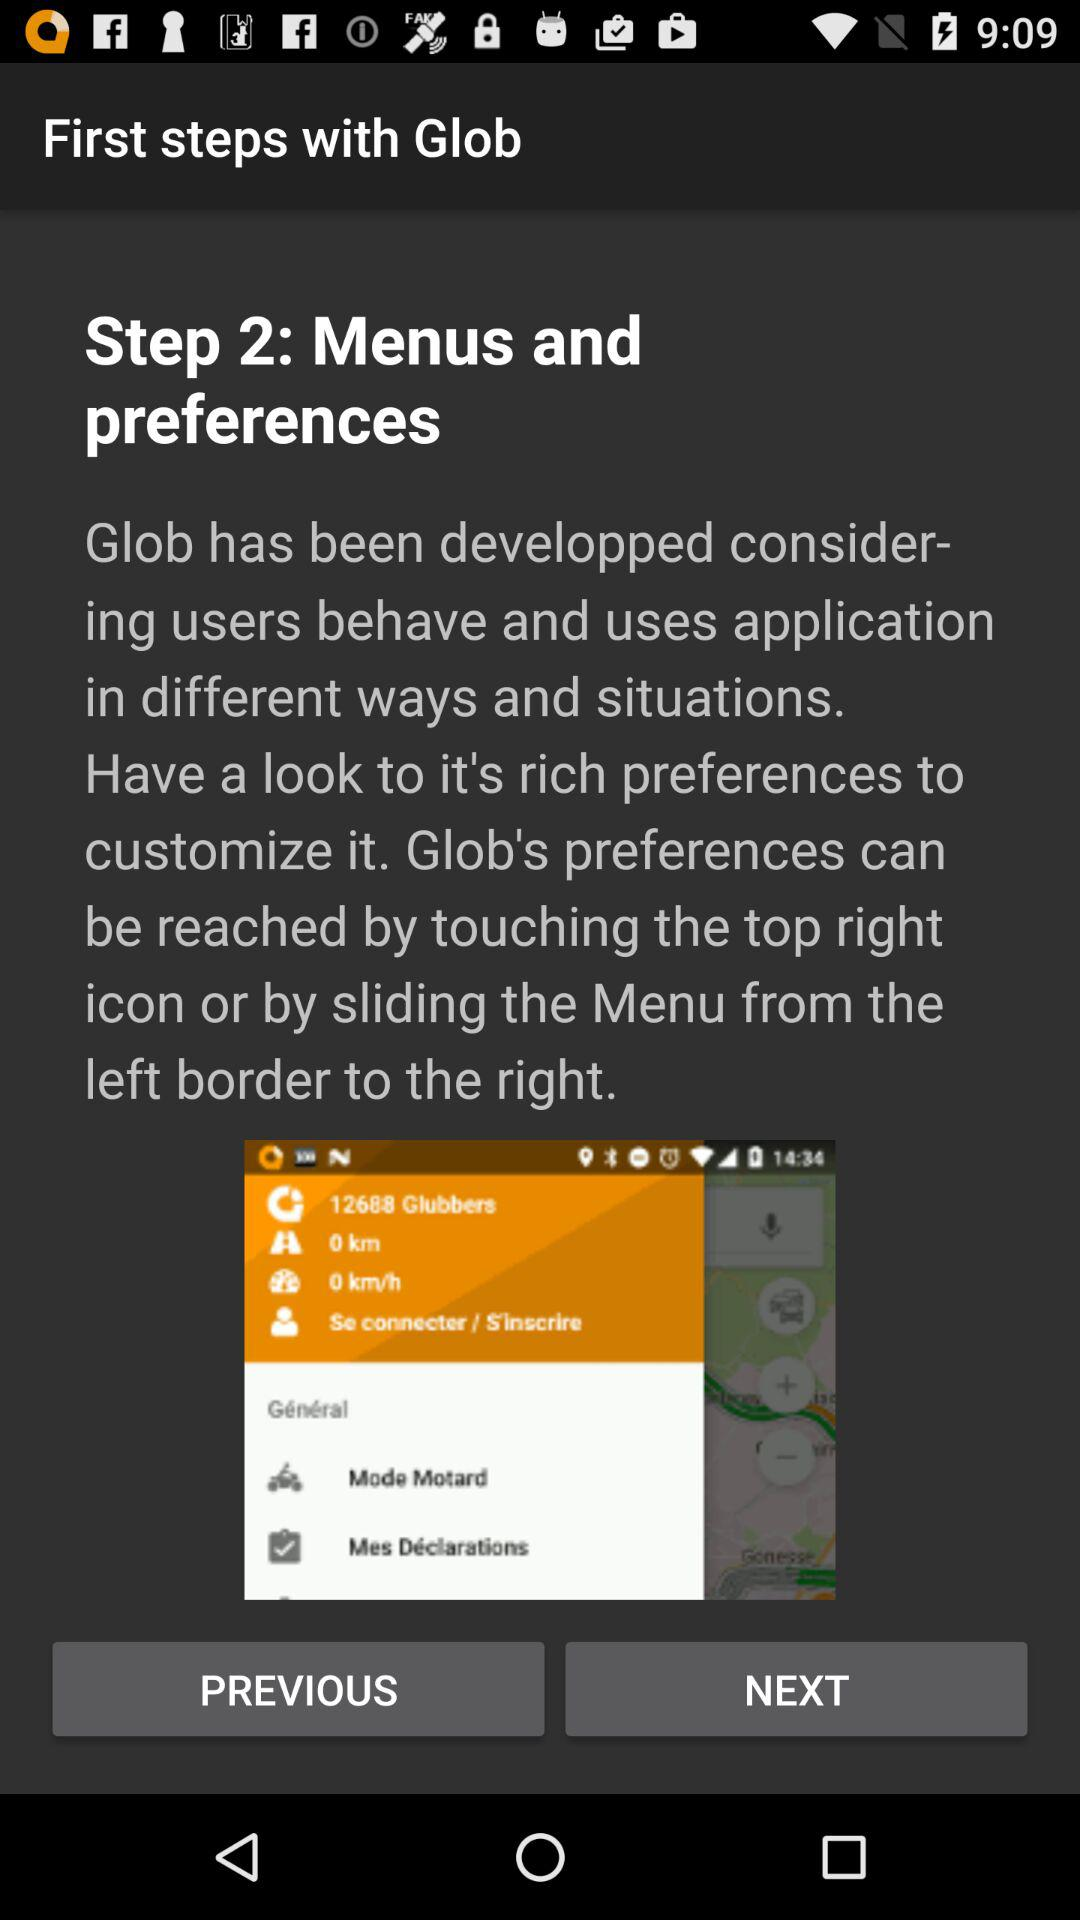What is step 2? Step 2 is "Menus and preferences". 